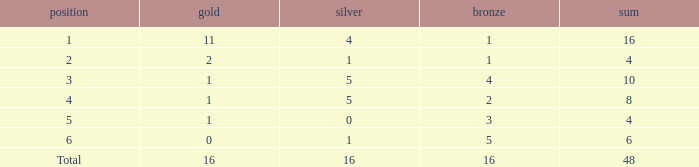How many total gold are less than 4? 0.0. 